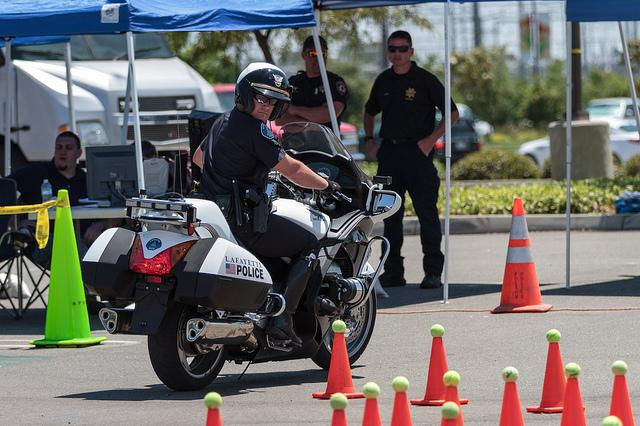What locale does the policeman serve? Please explain your reasoning. lafayette. The logo on the motorcycle says lafayette. 